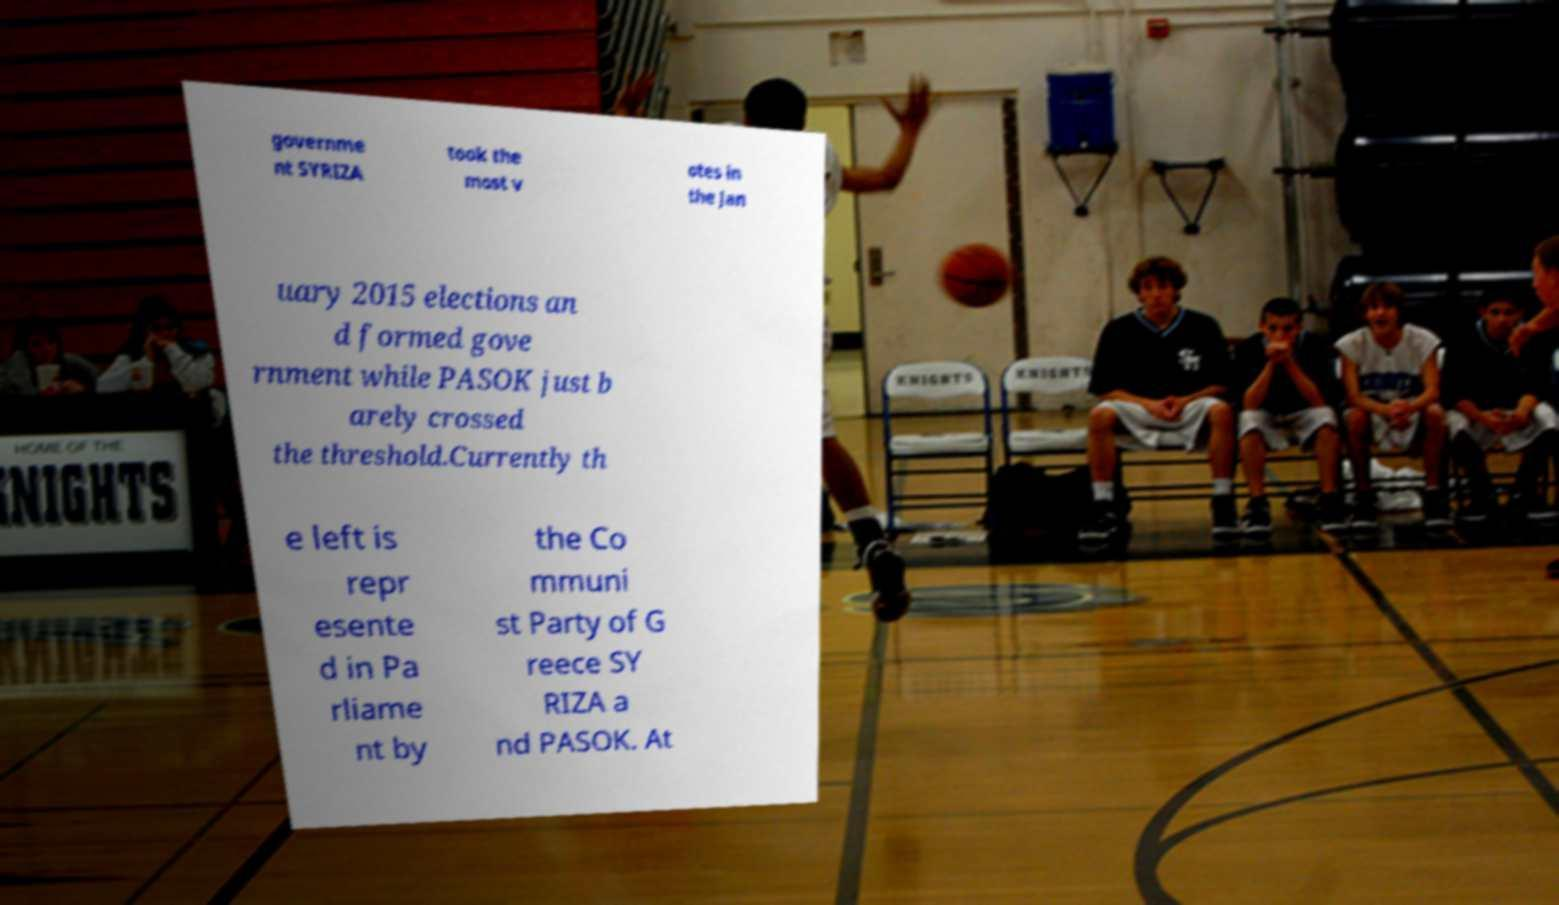There's text embedded in this image that I need extracted. Can you transcribe it verbatim? governme nt SYRIZA took the most v otes in the Jan uary 2015 elections an d formed gove rnment while PASOK just b arely crossed the threshold.Currently th e left is repr esente d in Pa rliame nt by the Co mmuni st Party of G reece SY RIZA a nd PASOK. At 